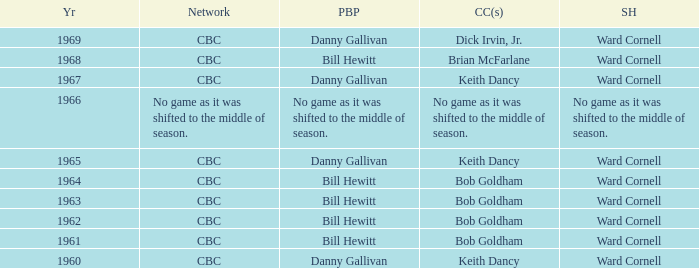Were the color commentators who worked with Bill Hewitt doing the play-by-play? Brian McFarlane, Bob Goldham, Bob Goldham, Bob Goldham, Bob Goldham. 